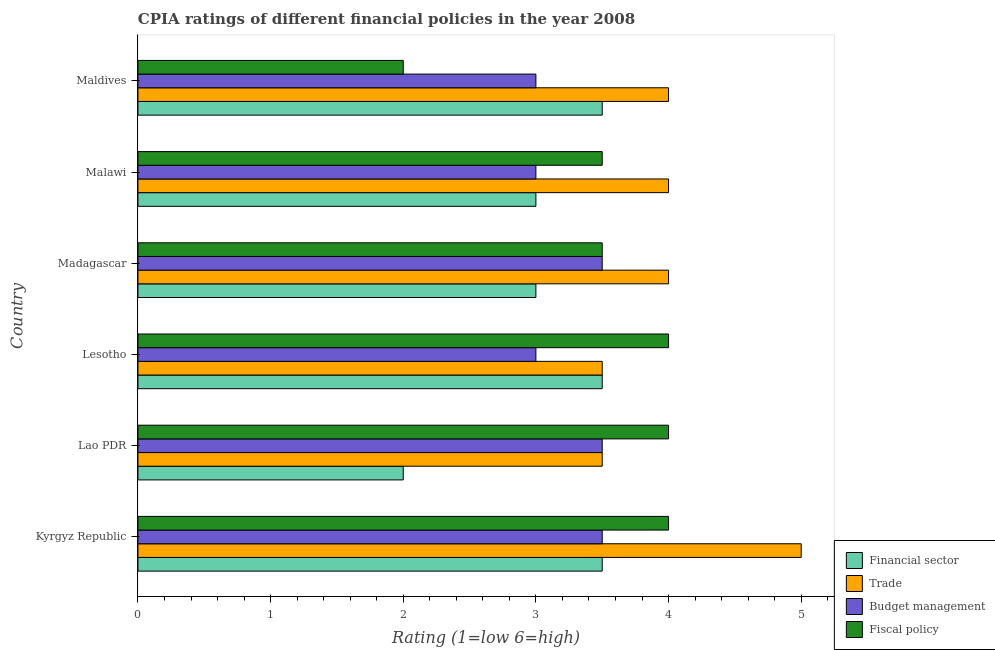How many different coloured bars are there?
Provide a succinct answer. 4. Are the number of bars per tick equal to the number of legend labels?
Your response must be concise. Yes. How many bars are there on the 2nd tick from the bottom?
Give a very brief answer. 4. What is the label of the 1st group of bars from the top?
Offer a terse response. Maldives. What is the cpia rating of budget management in Kyrgyz Republic?
Ensure brevity in your answer.  3.5. Across all countries, what is the maximum cpia rating of trade?
Offer a terse response. 5. In which country was the cpia rating of financial sector maximum?
Provide a succinct answer. Kyrgyz Republic. In which country was the cpia rating of trade minimum?
Provide a succinct answer. Lao PDR. What is the total cpia rating of financial sector in the graph?
Keep it short and to the point. 18.5. What is the difference between the cpia rating of trade in Malawi and that in Maldives?
Provide a succinct answer. 0. What is the difference between the cpia rating of fiscal policy in Kyrgyz Republic and the cpia rating of financial sector in Madagascar?
Offer a terse response. 1. What is the average cpia rating of trade per country?
Provide a short and direct response. 4. In how many countries, is the cpia rating of trade greater than 5 ?
Keep it short and to the point. 0. Is the cpia rating of fiscal policy in Kyrgyz Republic less than that in Malawi?
Provide a succinct answer. No. What is the difference between the highest and the second highest cpia rating of trade?
Your response must be concise. 1. Is the sum of the cpia rating of budget management in Kyrgyz Republic and Malawi greater than the maximum cpia rating of trade across all countries?
Provide a succinct answer. Yes. Is it the case that in every country, the sum of the cpia rating of fiscal policy and cpia rating of budget management is greater than the sum of cpia rating of trade and cpia rating of financial sector?
Provide a succinct answer. No. What does the 1st bar from the top in Lesotho represents?
Offer a terse response. Fiscal policy. What does the 2nd bar from the bottom in Madagascar represents?
Your response must be concise. Trade. Is it the case that in every country, the sum of the cpia rating of financial sector and cpia rating of trade is greater than the cpia rating of budget management?
Make the answer very short. Yes. How many bars are there?
Your answer should be very brief. 24. What is the difference between two consecutive major ticks on the X-axis?
Give a very brief answer. 1. Does the graph contain any zero values?
Provide a short and direct response. No. Does the graph contain grids?
Ensure brevity in your answer.  No. How many legend labels are there?
Your response must be concise. 4. How are the legend labels stacked?
Keep it short and to the point. Vertical. What is the title of the graph?
Keep it short and to the point. CPIA ratings of different financial policies in the year 2008. What is the label or title of the X-axis?
Make the answer very short. Rating (1=low 6=high). What is the Rating (1=low 6=high) of Budget management in Kyrgyz Republic?
Your response must be concise. 3.5. What is the Rating (1=low 6=high) of Fiscal policy in Kyrgyz Republic?
Provide a short and direct response. 4. What is the Rating (1=low 6=high) of Trade in Lao PDR?
Provide a short and direct response. 3.5. What is the Rating (1=low 6=high) of Financial sector in Lesotho?
Ensure brevity in your answer.  3.5. What is the Rating (1=low 6=high) of Fiscal policy in Madagascar?
Keep it short and to the point. 3.5. What is the Rating (1=low 6=high) in Financial sector in Malawi?
Your response must be concise. 3. What is the Rating (1=low 6=high) in Budget management in Malawi?
Provide a succinct answer. 3. What is the Rating (1=low 6=high) in Fiscal policy in Malawi?
Offer a terse response. 3.5. What is the Rating (1=low 6=high) of Budget management in Maldives?
Keep it short and to the point. 3. Across all countries, what is the maximum Rating (1=low 6=high) of Trade?
Your answer should be very brief. 5. Across all countries, what is the maximum Rating (1=low 6=high) of Budget management?
Provide a short and direct response. 3.5. Across all countries, what is the minimum Rating (1=low 6=high) of Financial sector?
Offer a very short reply. 2. Across all countries, what is the minimum Rating (1=low 6=high) in Fiscal policy?
Keep it short and to the point. 2. What is the total Rating (1=low 6=high) of Budget management in the graph?
Your response must be concise. 19.5. What is the difference between the Rating (1=low 6=high) of Financial sector in Kyrgyz Republic and that in Lao PDR?
Give a very brief answer. 1.5. What is the difference between the Rating (1=low 6=high) in Financial sector in Kyrgyz Republic and that in Lesotho?
Offer a terse response. 0. What is the difference between the Rating (1=low 6=high) of Trade in Kyrgyz Republic and that in Lesotho?
Your answer should be very brief. 1.5. What is the difference between the Rating (1=low 6=high) in Budget management in Kyrgyz Republic and that in Madagascar?
Offer a very short reply. 0. What is the difference between the Rating (1=low 6=high) of Fiscal policy in Kyrgyz Republic and that in Madagascar?
Keep it short and to the point. 0.5. What is the difference between the Rating (1=low 6=high) in Fiscal policy in Kyrgyz Republic and that in Malawi?
Your answer should be compact. 0.5. What is the difference between the Rating (1=low 6=high) in Financial sector in Kyrgyz Republic and that in Maldives?
Provide a succinct answer. 0. What is the difference between the Rating (1=low 6=high) of Budget management in Kyrgyz Republic and that in Maldives?
Your answer should be very brief. 0.5. What is the difference between the Rating (1=low 6=high) of Fiscal policy in Kyrgyz Republic and that in Maldives?
Provide a succinct answer. 2. What is the difference between the Rating (1=low 6=high) in Financial sector in Lao PDR and that in Lesotho?
Provide a succinct answer. -1.5. What is the difference between the Rating (1=low 6=high) in Trade in Lao PDR and that in Lesotho?
Your answer should be compact. 0. What is the difference between the Rating (1=low 6=high) in Budget management in Lao PDR and that in Lesotho?
Give a very brief answer. 0.5. What is the difference between the Rating (1=low 6=high) of Fiscal policy in Lao PDR and that in Maldives?
Offer a very short reply. 2. What is the difference between the Rating (1=low 6=high) in Budget management in Lesotho and that in Madagascar?
Offer a terse response. -0.5. What is the difference between the Rating (1=low 6=high) of Fiscal policy in Lesotho and that in Madagascar?
Your response must be concise. 0.5. What is the difference between the Rating (1=low 6=high) in Financial sector in Lesotho and that in Malawi?
Make the answer very short. 0.5. What is the difference between the Rating (1=low 6=high) in Trade in Lesotho and that in Malawi?
Ensure brevity in your answer.  -0.5. What is the difference between the Rating (1=low 6=high) of Budget management in Lesotho and that in Malawi?
Ensure brevity in your answer.  0. What is the difference between the Rating (1=low 6=high) of Fiscal policy in Lesotho and that in Malawi?
Provide a short and direct response. 0.5. What is the difference between the Rating (1=low 6=high) in Financial sector in Lesotho and that in Maldives?
Your answer should be very brief. 0. What is the difference between the Rating (1=low 6=high) of Trade in Lesotho and that in Maldives?
Offer a terse response. -0.5. What is the difference between the Rating (1=low 6=high) in Budget management in Lesotho and that in Maldives?
Your answer should be very brief. 0. What is the difference between the Rating (1=low 6=high) of Financial sector in Madagascar and that in Malawi?
Keep it short and to the point. 0. What is the difference between the Rating (1=low 6=high) in Budget management in Madagascar and that in Malawi?
Provide a succinct answer. 0.5. What is the difference between the Rating (1=low 6=high) in Fiscal policy in Madagascar and that in Malawi?
Your response must be concise. 0. What is the difference between the Rating (1=low 6=high) in Financial sector in Madagascar and that in Maldives?
Give a very brief answer. -0.5. What is the difference between the Rating (1=low 6=high) in Trade in Madagascar and that in Maldives?
Make the answer very short. 0. What is the difference between the Rating (1=low 6=high) of Budget management in Madagascar and that in Maldives?
Give a very brief answer. 0.5. What is the difference between the Rating (1=low 6=high) in Fiscal policy in Madagascar and that in Maldives?
Your answer should be very brief. 1.5. What is the difference between the Rating (1=low 6=high) in Financial sector in Malawi and that in Maldives?
Your answer should be compact. -0.5. What is the difference between the Rating (1=low 6=high) in Trade in Malawi and that in Maldives?
Provide a short and direct response. 0. What is the difference between the Rating (1=low 6=high) in Fiscal policy in Malawi and that in Maldives?
Provide a succinct answer. 1.5. What is the difference between the Rating (1=low 6=high) of Financial sector in Kyrgyz Republic and the Rating (1=low 6=high) of Trade in Lao PDR?
Provide a succinct answer. 0. What is the difference between the Rating (1=low 6=high) of Financial sector in Kyrgyz Republic and the Rating (1=low 6=high) of Fiscal policy in Lao PDR?
Keep it short and to the point. -0.5. What is the difference between the Rating (1=low 6=high) of Trade in Kyrgyz Republic and the Rating (1=low 6=high) of Budget management in Lao PDR?
Offer a terse response. 1.5. What is the difference between the Rating (1=low 6=high) in Trade in Kyrgyz Republic and the Rating (1=low 6=high) in Fiscal policy in Lao PDR?
Offer a very short reply. 1. What is the difference between the Rating (1=low 6=high) in Budget management in Kyrgyz Republic and the Rating (1=low 6=high) in Fiscal policy in Lao PDR?
Your answer should be compact. -0.5. What is the difference between the Rating (1=low 6=high) in Financial sector in Kyrgyz Republic and the Rating (1=low 6=high) in Trade in Lesotho?
Make the answer very short. 0. What is the difference between the Rating (1=low 6=high) of Financial sector in Kyrgyz Republic and the Rating (1=low 6=high) of Fiscal policy in Lesotho?
Give a very brief answer. -0.5. What is the difference between the Rating (1=low 6=high) of Budget management in Kyrgyz Republic and the Rating (1=low 6=high) of Fiscal policy in Lesotho?
Provide a short and direct response. -0.5. What is the difference between the Rating (1=low 6=high) of Financial sector in Kyrgyz Republic and the Rating (1=low 6=high) of Fiscal policy in Madagascar?
Your answer should be very brief. 0. What is the difference between the Rating (1=low 6=high) of Budget management in Kyrgyz Republic and the Rating (1=low 6=high) of Fiscal policy in Madagascar?
Make the answer very short. 0. What is the difference between the Rating (1=low 6=high) in Financial sector in Kyrgyz Republic and the Rating (1=low 6=high) in Trade in Malawi?
Provide a short and direct response. -0.5. What is the difference between the Rating (1=low 6=high) in Financial sector in Kyrgyz Republic and the Rating (1=low 6=high) in Fiscal policy in Malawi?
Make the answer very short. 0. What is the difference between the Rating (1=low 6=high) of Budget management in Kyrgyz Republic and the Rating (1=low 6=high) of Fiscal policy in Malawi?
Make the answer very short. 0. What is the difference between the Rating (1=low 6=high) of Financial sector in Kyrgyz Republic and the Rating (1=low 6=high) of Trade in Maldives?
Your answer should be compact. -0.5. What is the difference between the Rating (1=low 6=high) of Financial sector in Kyrgyz Republic and the Rating (1=low 6=high) of Budget management in Maldives?
Keep it short and to the point. 0.5. What is the difference between the Rating (1=low 6=high) of Trade in Kyrgyz Republic and the Rating (1=low 6=high) of Budget management in Maldives?
Your answer should be very brief. 2. What is the difference between the Rating (1=low 6=high) of Trade in Lao PDR and the Rating (1=low 6=high) of Budget management in Lesotho?
Offer a very short reply. 0.5. What is the difference between the Rating (1=low 6=high) in Budget management in Lao PDR and the Rating (1=low 6=high) in Fiscal policy in Lesotho?
Keep it short and to the point. -0.5. What is the difference between the Rating (1=low 6=high) of Financial sector in Lao PDR and the Rating (1=low 6=high) of Trade in Malawi?
Make the answer very short. -2. What is the difference between the Rating (1=low 6=high) in Financial sector in Lao PDR and the Rating (1=low 6=high) in Budget management in Malawi?
Keep it short and to the point. -1. What is the difference between the Rating (1=low 6=high) in Trade in Lao PDR and the Rating (1=low 6=high) in Budget management in Malawi?
Provide a short and direct response. 0.5. What is the difference between the Rating (1=low 6=high) in Financial sector in Lao PDR and the Rating (1=low 6=high) in Budget management in Maldives?
Make the answer very short. -1. What is the difference between the Rating (1=low 6=high) in Financial sector in Lao PDR and the Rating (1=low 6=high) in Fiscal policy in Maldives?
Provide a short and direct response. 0. What is the difference between the Rating (1=low 6=high) of Trade in Lao PDR and the Rating (1=low 6=high) of Budget management in Maldives?
Your response must be concise. 0.5. What is the difference between the Rating (1=low 6=high) in Budget management in Lao PDR and the Rating (1=low 6=high) in Fiscal policy in Maldives?
Your answer should be compact. 1.5. What is the difference between the Rating (1=low 6=high) of Financial sector in Lesotho and the Rating (1=low 6=high) of Budget management in Madagascar?
Offer a very short reply. 0. What is the difference between the Rating (1=low 6=high) of Financial sector in Lesotho and the Rating (1=low 6=high) of Fiscal policy in Madagascar?
Provide a short and direct response. 0. What is the difference between the Rating (1=low 6=high) in Trade in Lesotho and the Rating (1=low 6=high) in Budget management in Madagascar?
Provide a succinct answer. 0. What is the difference between the Rating (1=low 6=high) in Trade in Lesotho and the Rating (1=low 6=high) in Fiscal policy in Madagascar?
Your answer should be compact. 0. What is the difference between the Rating (1=low 6=high) of Financial sector in Lesotho and the Rating (1=low 6=high) of Fiscal policy in Malawi?
Offer a very short reply. 0. What is the difference between the Rating (1=low 6=high) of Trade in Lesotho and the Rating (1=low 6=high) of Fiscal policy in Malawi?
Make the answer very short. 0. What is the difference between the Rating (1=low 6=high) in Budget management in Lesotho and the Rating (1=low 6=high) in Fiscal policy in Malawi?
Give a very brief answer. -0.5. What is the difference between the Rating (1=low 6=high) of Financial sector in Lesotho and the Rating (1=low 6=high) of Budget management in Maldives?
Ensure brevity in your answer.  0.5. What is the difference between the Rating (1=low 6=high) in Financial sector in Lesotho and the Rating (1=low 6=high) in Fiscal policy in Maldives?
Your answer should be very brief. 1.5. What is the difference between the Rating (1=low 6=high) of Trade in Lesotho and the Rating (1=low 6=high) of Fiscal policy in Maldives?
Offer a terse response. 1.5. What is the difference between the Rating (1=low 6=high) of Budget management in Lesotho and the Rating (1=low 6=high) of Fiscal policy in Maldives?
Your response must be concise. 1. What is the difference between the Rating (1=low 6=high) in Financial sector in Madagascar and the Rating (1=low 6=high) in Budget management in Malawi?
Your answer should be very brief. 0. What is the difference between the Rating (1=low 6=high) in Financial sector in Madagascar and the Rating (1=low 6=high) in Fiscal policy in Malawi?
Your response must be concise. -0.5. What is the difference between the Rating (1=low 6=high) of Trade in Madagascar and the Rating (1=low 6=high) of Fiscal policy in Malawi?
Provide a short and direct response. 0.5. What is the difference between the Rating (1=low 6=high) in Financial sector in Madagascar and the Rating (1=low 6=high) in Trade in Maldives?
Keep it short and to the point. -1. What is the difference between the Rating (1=low 6=high) of Financial sector in Madagascar and the Rating (1=low 6=high) of Budget management in Maldives?
Offer a terse response. 0. What is the difference between the Rating (1=low 6=high) in Financial sector in Madagascar and the Rating (1=low 6=high) in Fiscal policy in Maldives?
Offer a terse response. 1. What is the difference between the Rating (1=low 6=high) of Trade in Madagascar and the Rating (1=low 6=high) of Budget management in Maldives?
Provide a short and direct response. 1. What is the difference between the Rating (1=low 6=high) of Trade in Madagascar and the Rating (1=low 6=high) of Fiscal policy in Maldives?
Keep it short and to the point. 2. What is the difference between the Rating (1=low 6=high) of Financial sector in Malawi and the Rating (1=low 6=high) of Fiscal policy in Maldives?
Offer a very short reply. 1. What is the difference between the Rating (1=low 6=high) of Trade in Malawi and the Rating (1=low 6=high) of Fiscal policy in Maldives?
Your answer should be compact. 2. What is the average Rating (1=low 6=high) of Financial sector per country?
Make the answer very short. 3.08. What is the average Rating (1=low 6=high) of Fiscal policy per country?
Give a very brief answer. 3.5. What is the difference between the Rating (1=low 6=high) of Financial sector and Rating (1=low 6=high) of Trade in Kyrgyz Republic?
Provide a short and direct response. -1.5. What is the difference between the Rating (1=low 6=high) in Financial sector and Rating (1=low 6=high) in Budget management in Kyrgyz Republic?
Make the answer very short. 0. What is the difference between the Rating (1=low 6=high) in Financial sector and Rating (1=low 6=high) in Fiscal policy in Kyrgyz Republic?
Provide a short and direct response. -0.5. What is the difference between the Rating (1=low 6=high) in Trade and Rating (1=low 6=high) in Budget management in Kyrgyz Republic?
Your response must be concise. 1.5. What is the difference between the Rating (1=low 6=high) in Trade and Rating (1=low 6=high) in Fiscal policy in Kyrgyz Republic?
Your response must be concise. 1. What is the difference between the Rating (1=low 6=high) in Financial sector and Rating (1=low 6=high) in Trade in Lesotho?
Offer a terse response. 0. What is the difference between the Rating (1=low 6=high) of Trade and Rating (1=low 6=high) of Fiscal policy in Lesotho?
Your answer should be very brief. -0.5. What is the difference between the Rating (1=low 6=high) of Financial sector and Rating (1=low 6=high) of Trade in Madagascar?
Your answer should be very brief. -1. What is the difference between the Rating (1=low 6=high) in Financial sector and Rating (1=low 6=high) in Budget management in Madagascar?
Your answer should be very brief. -0.5. What is the difference between the Rating (1=low 6=high) in Trade and Rating (1=low 6=high) in Budget management in Malawi?
Offer a very short reply. 1. What is the difference between the Rating (1=low 6=high) of Trade and Rating (1=low 6=high) of Fiscal policy in Malawi?
Offer a very short reply. 0.5. What is the difference between the Rating (1=low 6=high) of Budget management and Rating (1=low 6=high) of Fiscal policy in Malawi?
Your answer should be compact. -0.5. What is the difference between the Rating (1=low 6=high) of Financial sector and Rating (1=low 6=high) of Trade in Maldives?
Your answer should be very brief. -0.5. What is the difference between the Rating (1=low 6=high) in Financial sector and Rating (1=low 6=high) in Budget management in Maldives?
Offer a terse response. 0.5. What is the difference between the Rating (1=low 6=high) of Financial sector and Rating (1=low 6=high) of Fiscal policy in Maldives?
Your answer should be compact. 1.5. What is the difference between the Rating (1=low 6=high) in Trade and Rating (1=low 6=high) in Budget management in Maldives?
Keep it short and to the point. 1. What is the ratio of the Rating (1=low 6=high) of Trade in Kyrgyz Republic to that in Lao PDR?
Your answer should be very brief. 1.43. What is the ratio of the Rating (1=low 6=high) in Fiscal policy in Kyrgyz Republic to that in Lao PDR?
Your answer should be very brief. 1. What is the ratio of the Rating (1=low 6=high) in Trade in Kyrgyz Republic to that in Lesotho?
Provide a succinct answer. 1.43. What is the ratio of the Rating (1=low 6=high) of Fiscal policy in Kyrgyz Republic to that in Madagascar?
Ensure brevity in your answer.  1.14. What is the ratio of the Rating (1=low 6=high) in Financial sector in Kyrgyz Republic to that in Malawi?
Your response must be concise. 1.17. What is the ratio of the Rating (1=low 6=high) of Trade in Kyrgyz Republic to that in Malawi?
Ensure brevity in your answer.  1.25. What is the ratio of the Rating (1=low 6=high) in Budget management in Kyrgyz Republic to that in Malawi?
Offer a very short reply. 1.17. What is the ratio of the Rating (1=low 6=high) in Trade in Kyrgyz Republic to that in Maldives?
Ensure brevity in your answer.  1.25. What is the ratio of the Rating (1=low 6=high) in Fiscal policy in Lao PDR to that in Lesotho?
Your response must be concise. 1. What is the ratio of the Rating (1=low 6=high) of Financial sector in Lao PDR to that in Madagascar?
Keep it short and to the point. 0.67. What is the ratio of the Rating (1=low 6=high) of Fiscal policy in Lao PDR to that in Madagascar?
Keep it short and to the point. 1.14. What is the ratio of the Rating (1=low 6=high) in Trade in Lao PDR to that in Malawi?
Provide a succinct answer. 0.88. What is the ratio of the Rating (1=low 6=high) of Fiscal policy in Lao PDR to that in Malawi?
Offer a very short reply. 1.14. What is the ratio of the Rating (1=low 6=high) of Financial sector in Lao PDR to that in Maldives?
Make the answer very short. 0.57. What is the ratio of the Rating (1=low 6=high) in Budget management in Lao PDR to that in Maldives?
Your answer should be very brief. 1.17. What is the ratio of the Rating (1=low 6=high) of Trade in Lesotho to that in Madagascar?
Your response must be concise. 0.88. What is the ratio of the Rating (1=low 6=high) in Fiscal policy in Lesotho to that in Madagascar?
Your answer should be very brief. 1.14. What is the ratio of the Rating (1=low 6=high) of Financial sector in Lesotho to that in Malawi?
Your answer should be compact. 1.17. What is the ratio of the Rating (1=low 6=high) of Trade in Lesotho to that in Malawi?
Offer a very short reply. 0.88. What is the ratio of the Rating (1=low 6=high) in Budget management in Lesotho to that in Malawi?
Make the answer very short. 1. What is the ratio of the Rating (1=low 6=high) in Financial sector in Lesotho to that in Maldives?
Give a very brief answer. 1. What is the ratio of the Rating (1=low 6=high) in Trade in Lesotho to that in Maldives?
Provide a succinct answer. 0.88. What is the ratio of the Rating (1=low 6=high) of Budget management in Lesotho to that in Maldives?
Provide a short and direct response. 1. What is the ratio of the Rating (1=low 6=high) of Budget management in Madagascar to that in Malawi?
Your answer should be compact. 1.17. What is the ratio of the Rating (1=low 6=high) of Trade in Madagascar to that in Maldives?
Offer a terse response. 1. What is the ratio of the Rating (1=low 6=high) in Budget management in Madagascar to that in Maldives?
Offer a terse response. 1.17. What is the ratio of the Rating (1=low 6=high) in Fiscal policy in Madagascar to that in Maldives?
Your answer should be very brief. 1.75. What is the ratio of the Rating (1=low 6=high) in Financial sector in Malawi to that in Maldives?
Provide a short and direct response. 0.86. What is the ratio of the Rating (1=low 6=high) of Budget management in Malawi to that in Maldives?
Your response must be concise. 1. What is the difference between the highest and the second highest Rating (1=low 6=high) in Financial sector?
Give a very brief answer. 0. What is the difference between the highest and the second highest Rating (1=low 6=high) of Trade?
Make the answer very short. 1. What is the difference between the highest and the second highest Rating (1=low 6=high) of Budget management?
Your answer should be very brief. 0. What is the difference between the highest and the lowest Rating (1=low 6=high) of Fiscal policy?
Make the answer very short. 2. 